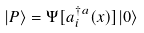<formula> <loc_0><loc_0><loc_500><loc_500>| P \rangle = \Psi [ a ^ { \dagger a } _ { i } ( x ) ] | 0 \rangle</formula> 